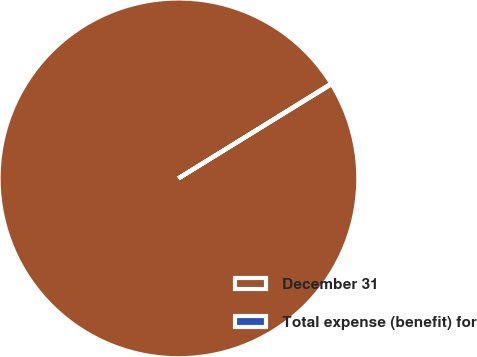<chart> <loc_0><loc_0><loc_500><loc_500><pie_chart><fcel>December 31<fcel>Total expense (benefit) for<nl><fcel>99.95%<fcel>0.05%<nl></chart> 